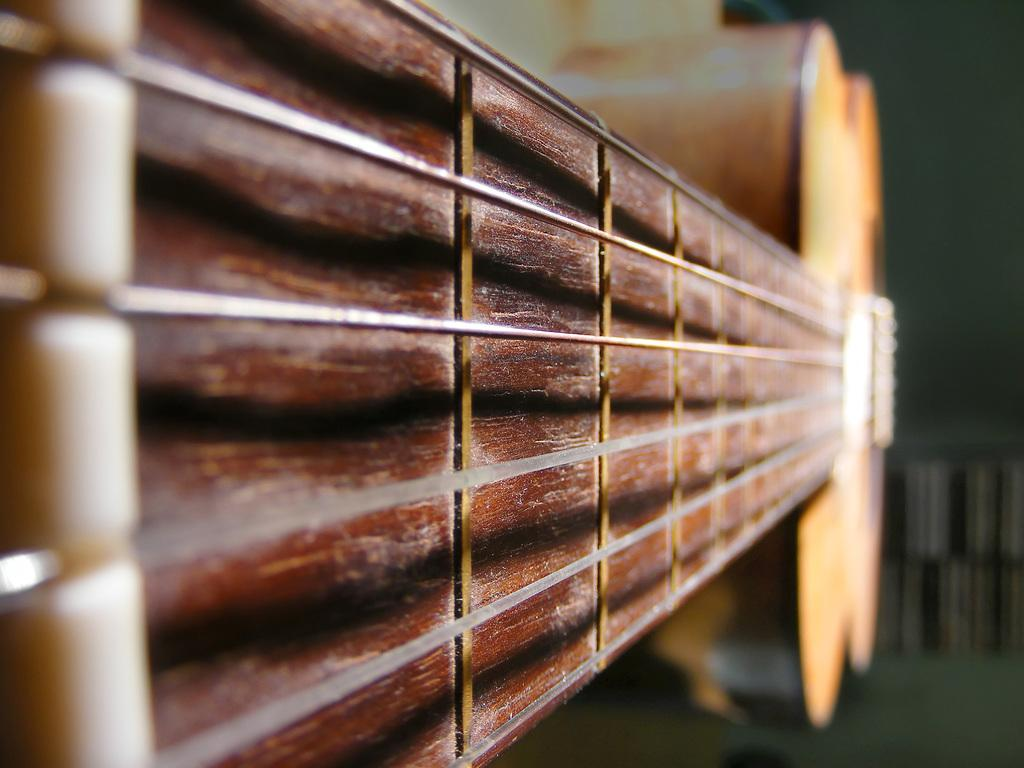What musical instrument is featured in the image? The strings of a guitar are featured in the image. What can be inferred about the color of the guitar or its surroundings? The background of the image is brown in color. What type of vegetable is being stored in the basket in the image? There is no basket or vegetable present in the image; it only features the strings of a guitar. 